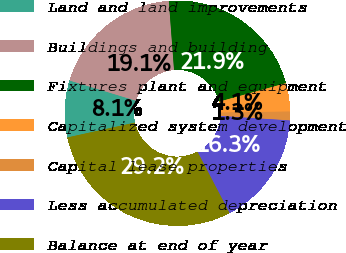Convert chart. <chart><loc_0><loc_0><loc_500><loc_500><pie_chart><fcel>Land and land improvements<fcel>Buildings and building<fcel>Fixtures plant and equipment<fcel>Capitalized system development<fcel>Capital lease properties<fcel>Less accumulated depreciation<fcel>Balance at end of year<nl><fcel>8.15%<fcel>19.1%<fcel>21.9%<fcel>4.06%<fcel>1.26%<fcel>16.31%<fcel>29.22%<nl></chart> 